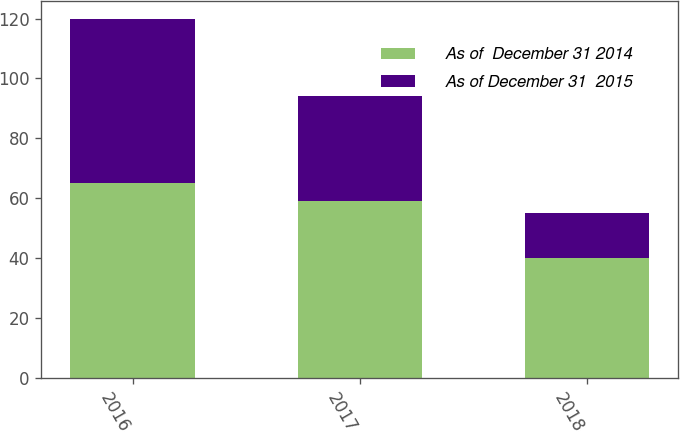Convert chart. <chart><loc_0><loc_0><loc_500><loc_500><stacked_bar_chart><ecel><fcel>2016<fcel>2017<fcel>2018<nl><fcel>As of  December 31 2014<fcel>65<fcel>59<fcel>40<nl><fcel>As of December 31  2015<fcel>55<fcel>35<fcel>15<nl></chart> 